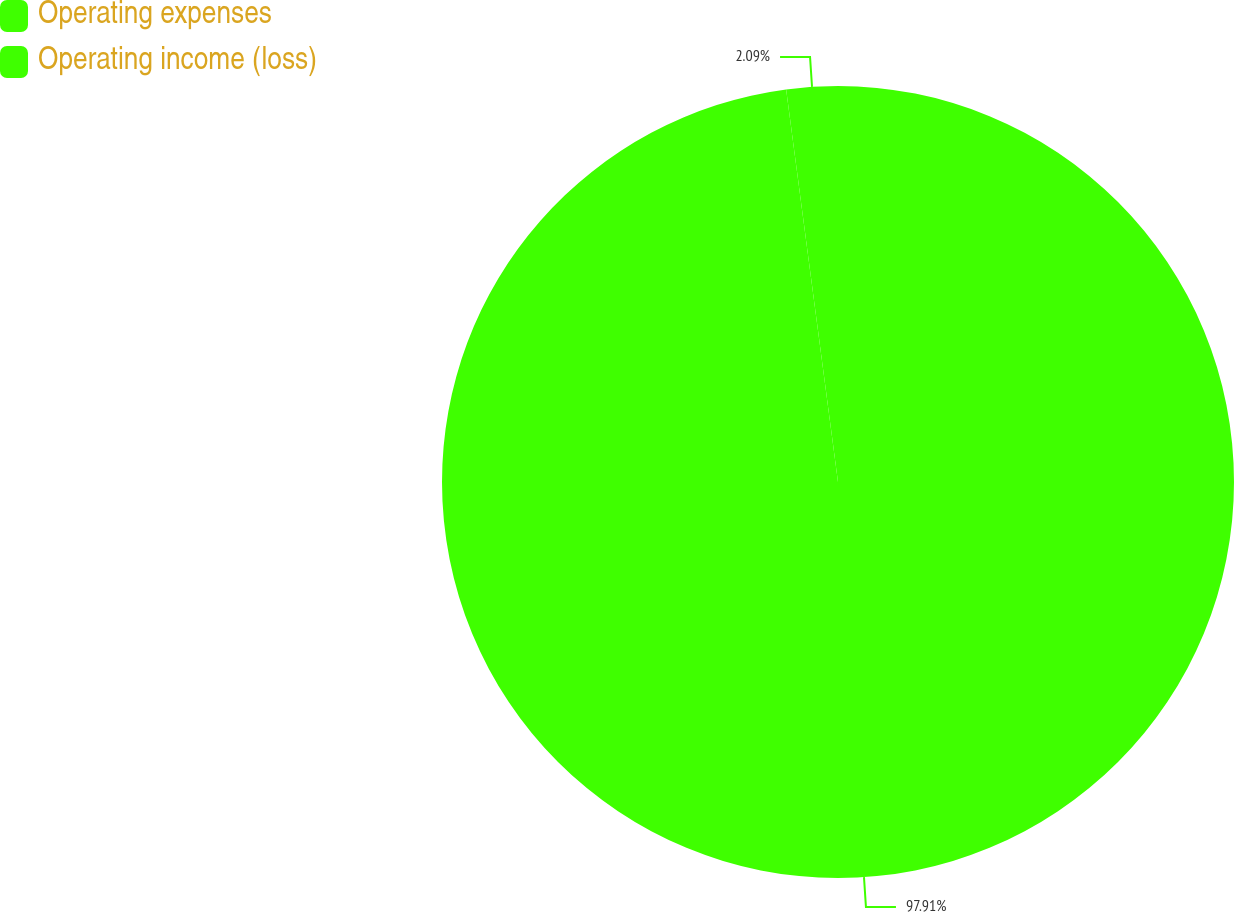Convert chart. <chart><loc_0><loc_0><loc_500><loc_500><pie_chart><fcel>Operating expenses<fcel>Operating income (loss)<nl><fcel>97.91%<fcel>2.09%<nl></chart> 